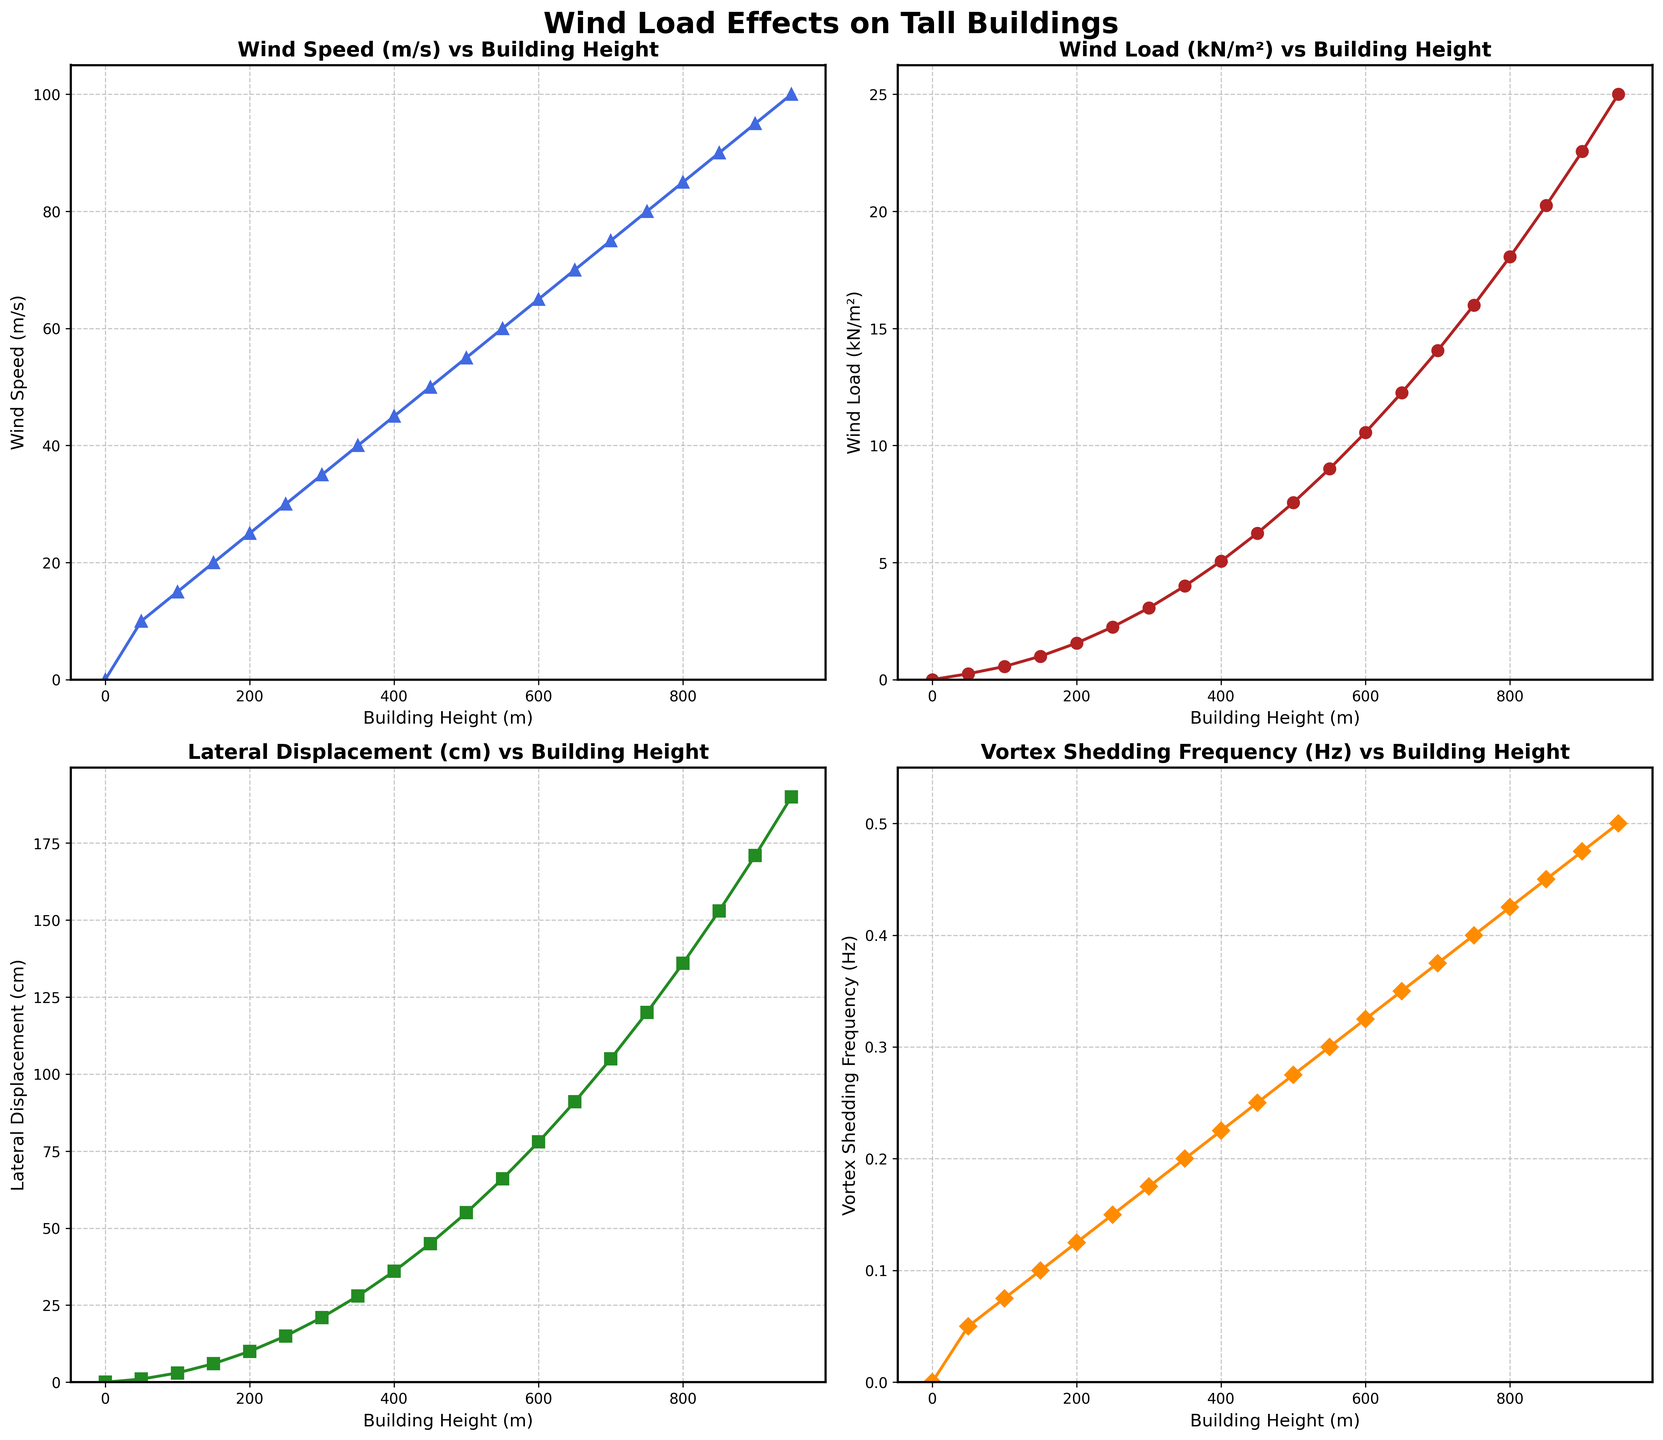What's the height at which the wind speed first reaches 45 m/s? According to the plot, locate the point on the 'Wind Speed (m/s)' subplot where the wind speed first reaches 45 m/s and trace it to the corresponding building height on the x-axis.
Answer: 400 m How much does the lateral displacement increase between 300 m and 500 m? Find the lateral displacement values at 300 m and 500 m on the relevant subplot. Subtract the displacement at 300 m from the displacement at 500 m (55 cm - 21 cm).
Answer: 34 cm Between which two building heights does the vortex shedding frequency increase the most? Examine the rate of change between consecutive points on the 'Vortex Shedding Frequency (Hz)' subplot. Identify the two points with the highest difference.
Answer: 0.05 Hz between 0 m and 50 m What is the average wind load between 200 m and 600 m? Identify the wind load values at building heights 200 m, 250 m, 300 m, 350 m, 400 m, 450 m, 500 m, and 600 m. Sum these values and divide by the number of points (1.56 + 2.25 + 3.06 + 4 + 5.06 + 6.25 + 7.56 + 10.56) / 8.
Answer: 5.16 kN/m² Which parameter shows the steepest increase as the building height increases? Compare the gradients of the plots for different parameters by looking at how quickly the values on the y-axis rise as the x-axis increases. The parameter with the steepest slope will have the largest increase.
Answer: Wind Speed (m/s) At which height do both the wind load and the lateral displacement reach their maximum values? Identify the building height at which the peak values occur for both the 'Wind Load (kN/m²)' and 'Lateral Displacement (cm)' subplots. Both maxima are at the same height.
Answer: 950 m Which subplot shows a linear relationship? Look for the subplot where the data points form a straight-line trend. This would typically be indicated by a roughly constant rate of change.
Answer: Wind Speed (m/s) How much higher is the vortex shedding frequency at 900 m compared to 450 m? Locate the vortex shedding frequency values at 900 m and 450 m on the 'Vortex Shedding Frequency (Hz)' subplot. Subtract the frequency at 450 m (0.25 Hz) from the frequency at 900 m (0.475 Hz).
Answer: 0.225 Hz What is the rate of change in wind load per meter between 200 m and 400 m? Calculate the difference in wind load between 200 m and 400 m (5.06 - 1.56) and divide by the difference in heights (400 m - 200 m).
Answer: 1.75 x 10^-2 kN/m²/m 